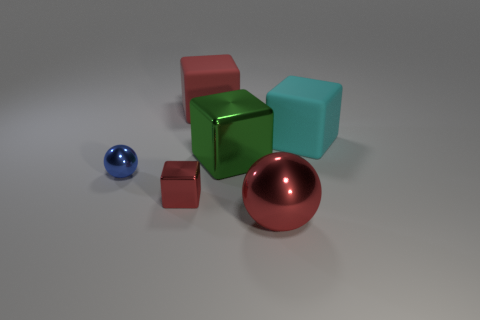Are there an equal number of big cyan rubber cubes that are to the left of the cyan matte block and large green metallic blocks?
Provide a short and direct response. No. There is a small ball; is its color the same as the matte cube that is behind the cyan cube?
Your answer should be compact. No. What is the color of the cube that is both behind the large green thing and left of the big green cube?
Offer a terse response. Red. There is a big red thing that is behind the big green thing; what number of green metal cubes are in front of it?
Give a very brief answer. 1. Are there any big red metal things of the same shape as the tiny blue metal thing?
Ensure brevity in your answer.  Yes. There is a large red thing that is in front of the cyan matte block; is it the same shape as the thing that is on the left side of the small metal block?
Your answer should be very brief. Yes. What number of things are tiny green matte cylinders or large cubes?
Your answer should be very brief. 3. The other rubber thing that is the same shape as the cyan thing is what size?
Keep it short and to the point. Large. Is the number of red blocks that are in front of the blue object greater than the number of tiny gray cubes?
Keep it short and to the point. Yes. Are the large cyan thing and the big green object made of the same material?
Offer a terse response. No. 